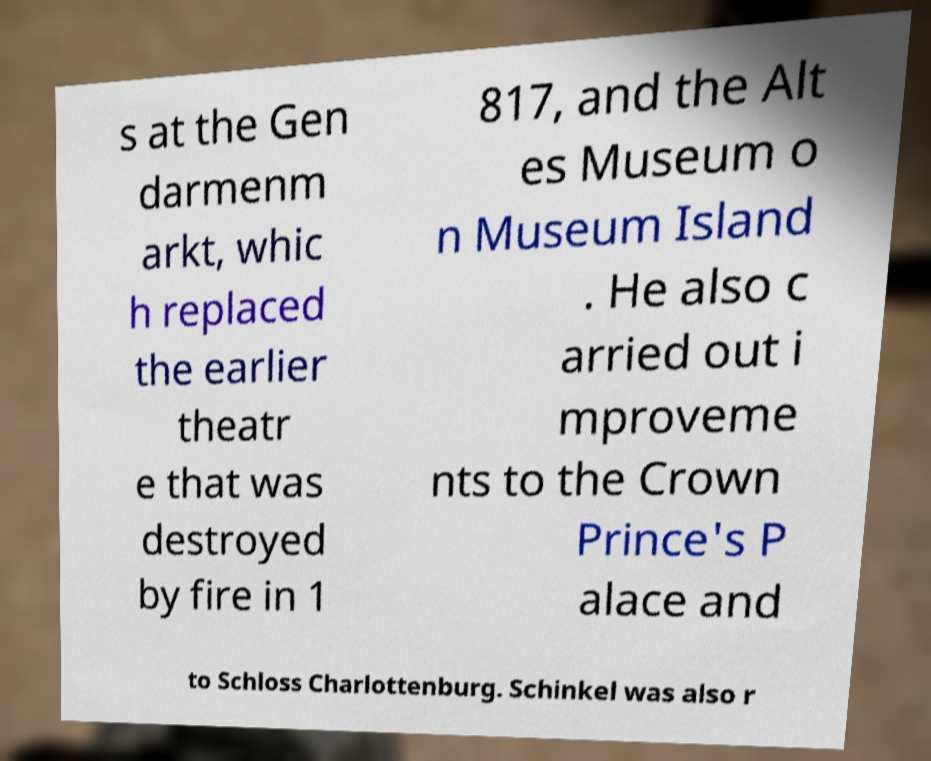Could you assist in decoding the text presented in this image and type it out clearly? s at the Gen darmenm arkt, whic h replaced the earlier theatr e that was destroyed by fire in 1 817, and the Alt es Museum o n Museum Island . He also c arried out i mproveme nts to the Crown Prince's P alace and to Schloss Charlottenburg. Schinkel was also r 